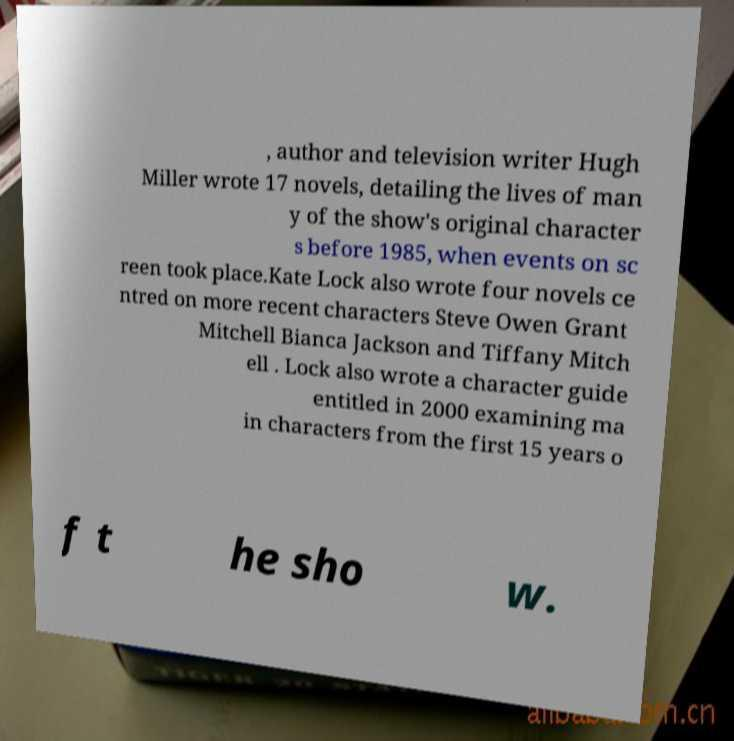I need the written content from this picture converted into text. Can you do that? , author and television writer Hugh Miller wrote 17 novels, detailing the lives of man y of the show's original character s before 1985, when events on sc reen took place.Kate Lock also wrote four novels ce ntred on more recent characters Steve Owen Grant Mitchell Bianca Jackson and Tiffany Mitch ell . Lock also wrote a character guide entitled in 2000 examining ma in characters from the first 15 years o f t he sho w. 